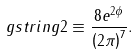<formula> <loc_0><loc_0><loc_500><loc_500>\ g s t r i n g { 2 } \equiv \frac { 8 e ^ { 2 \phi } } { \left ( 2 \pi \right ) ^ { 7 } } .</formula> 